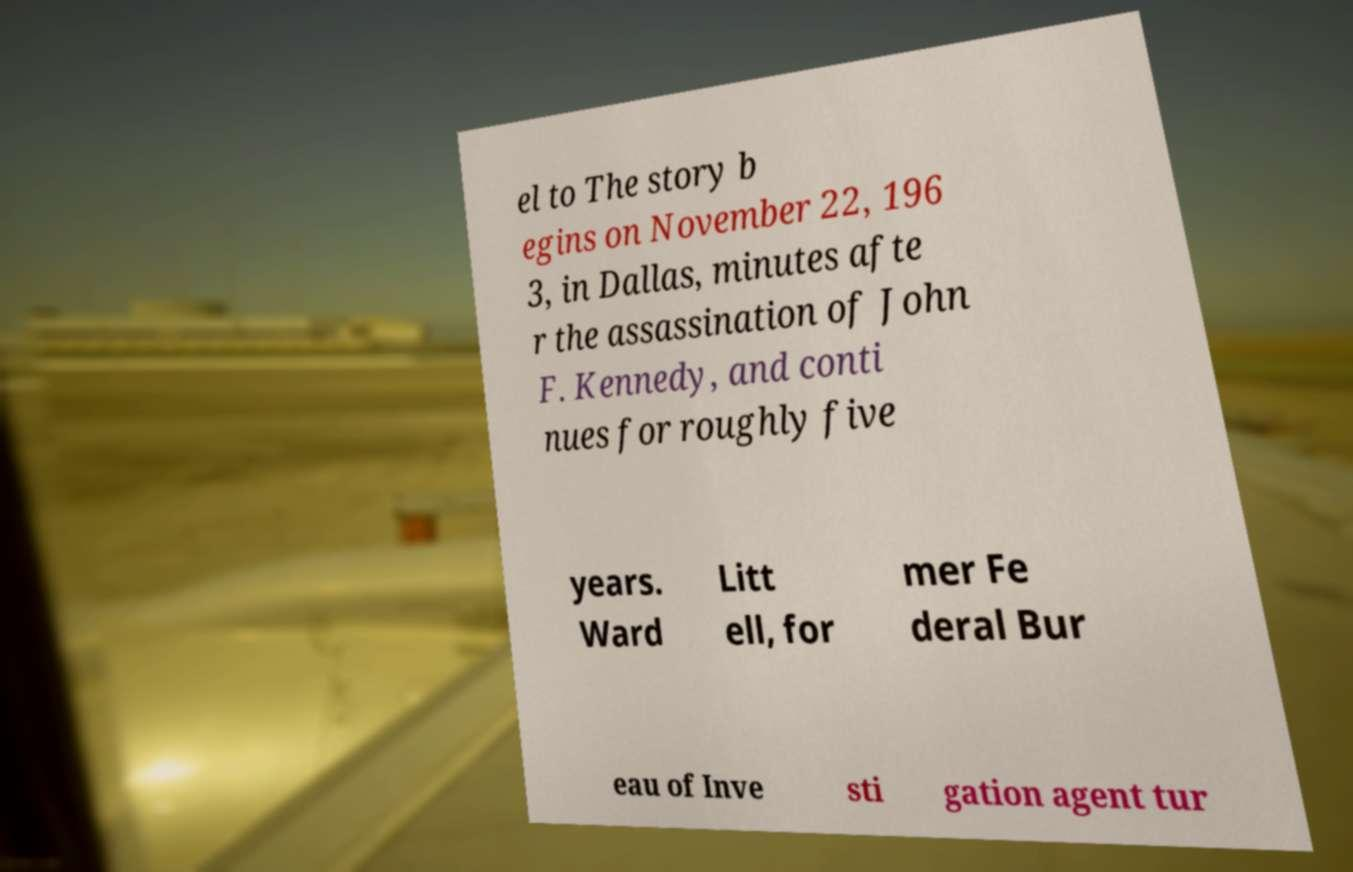Could you assist in decoding the text presented in this image and type it out clearly? el to The story b egins on November 22, 196 3, in Dallas, minutes afte r the assassination of John F. Kennedy, and conti nues for roughly five years. Ward Litt ell, for mer Fe deral Bur eau of Inve sti gation agent tur 